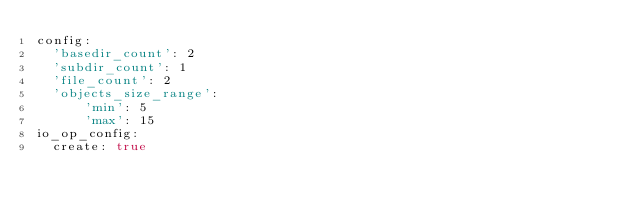Convert code to text. <code><loc_0><loc_0><loc_500><loc_500><_YAML_>config:
  'basedir_count': 2
  'subdir_count': 1
  'file_count': 2
  'objects_size_range':
      'min': 5
      'max': 15
io_op_config:
  create: true</code> 